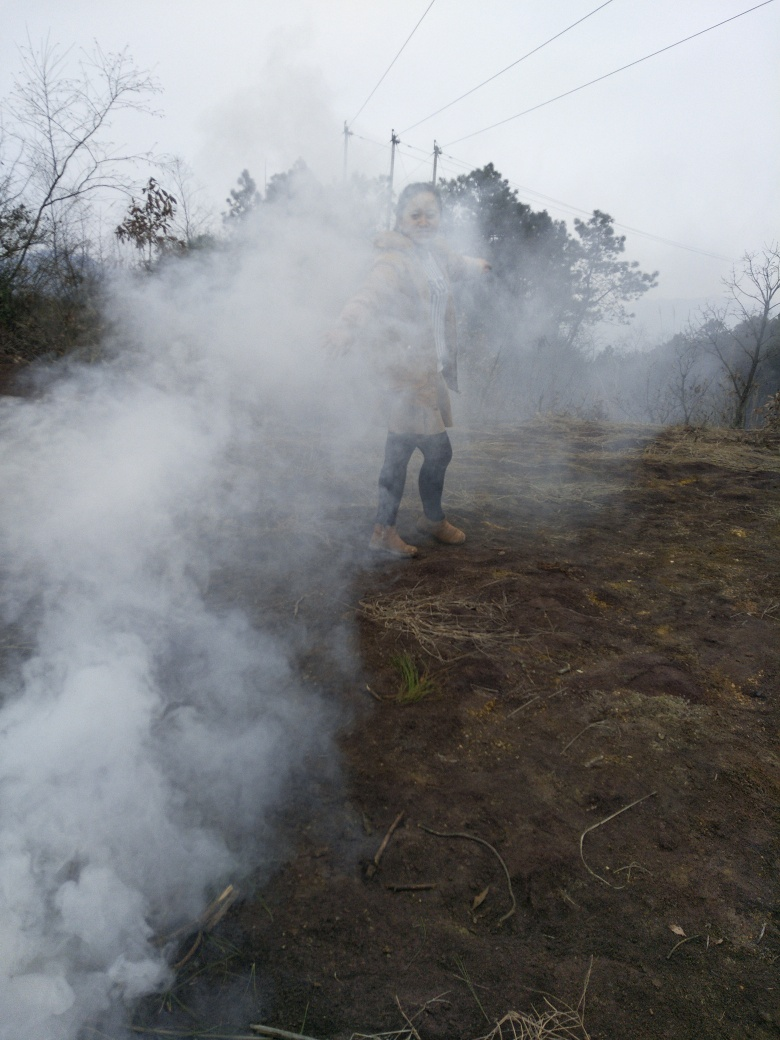Can you describe the weather conditions visible in the image? The sky looks overcast with a blanket of grey clouds suggesting it might be a cool or damp day. The visibility is fair apart from the area shrouded by smoke, and no precipitation is evident in the image. The atmosphere gives the impression of a subdued, possibly chilly environment which is in contrast to the smoke that implies an active fire or heat source nearby. 